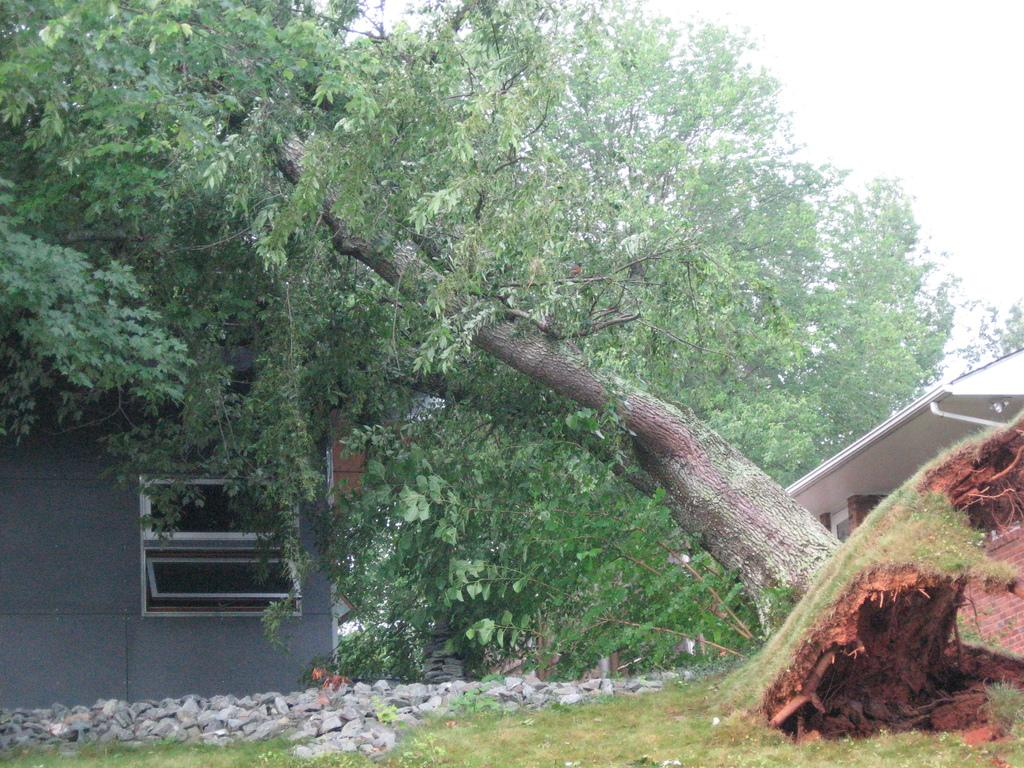What is the main object in the image? There is a tree in the image. What is the condition of the tree? The tree is fallen on a building. What is in front of the building? There is a small rock fence in front of the building. What can be seen above the scene? The sky is visible above the scene. What type of art is being selected for the building's interior in the image? There is no mention of art or selection in the image; it primarily features a fallen tree on a building and a small rock fence. 